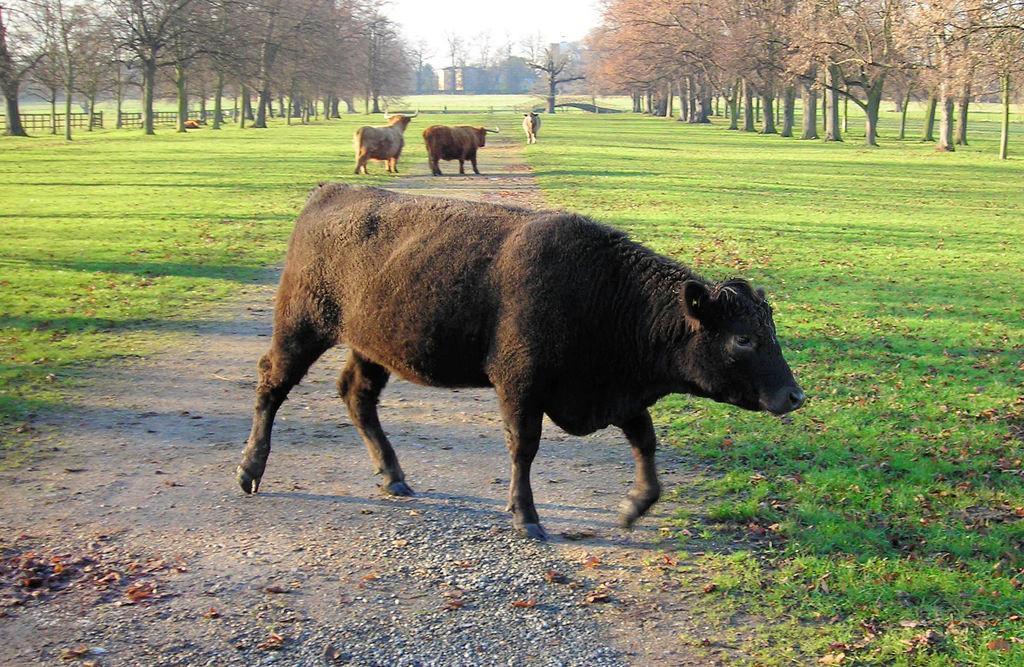How would you summarize this image in a sentence or two? In this image there is a path on which there are four bulls which are walking on it. There are trees on either side of the path. On the ground there is grass. 